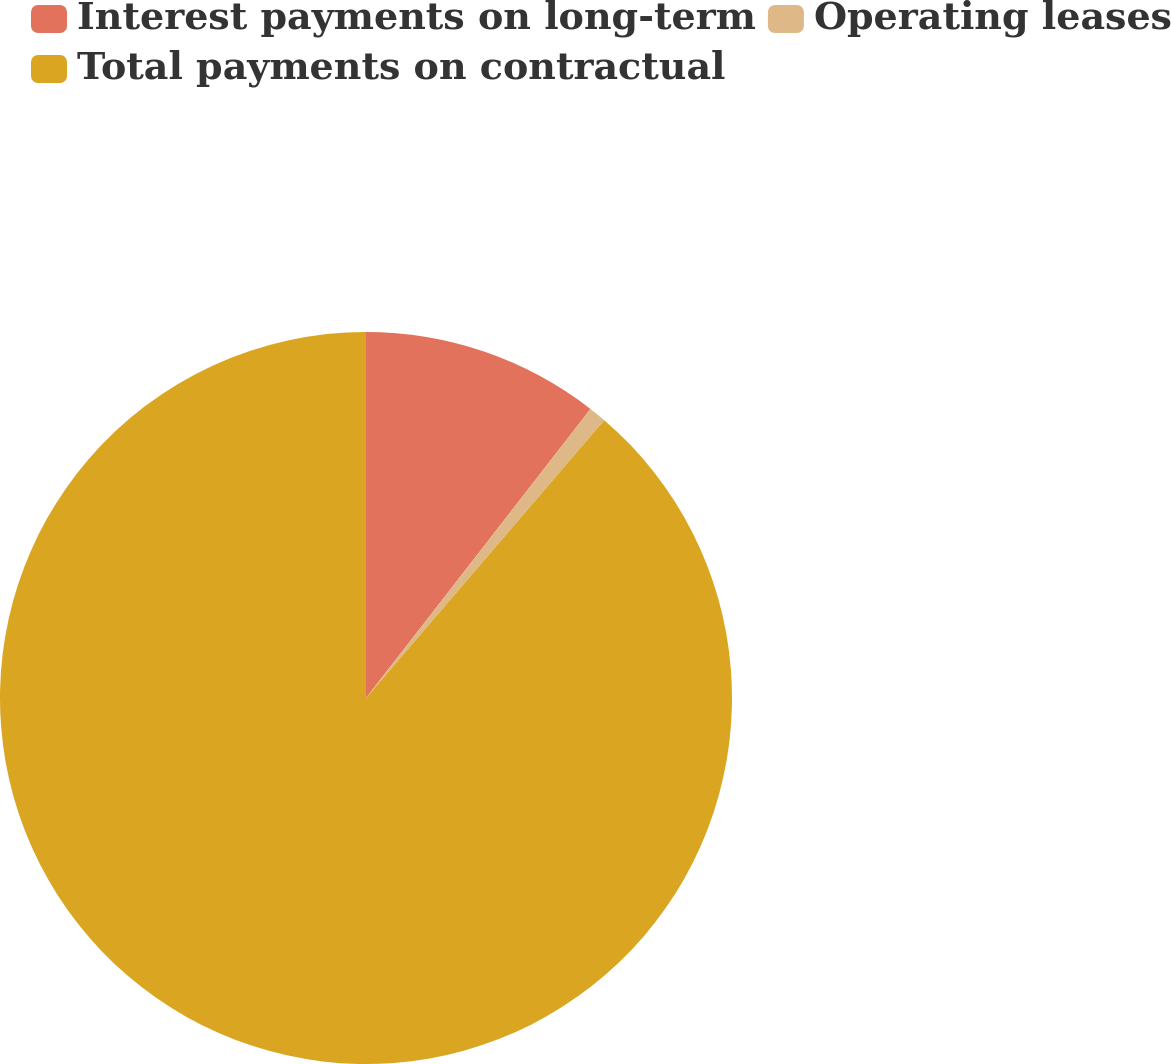Convert chart to OTSL. <chart><loc_0><loc_0><loc_500><loc_500><pie_chart><fcel>Interest payments on long-term<fcel>Operating leases<fcel>Total payments on contractual<nl><fcel>10.51%<fcel>0.77%<fcel>88.72%<nl></chart> 